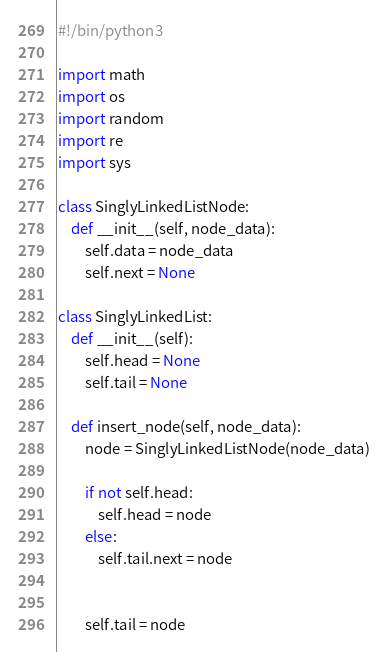Convert code to text. <code><loc_0><loc_0><loc_500><loc_500><_Python_>#!/bin/python3

import math
import os
import random
import re
import sys

class SinglyLinkedListNode:
    def __init__(self, node_data):
        self.data = node_data
        self.next = None

class SinglyLinkedList:
    def __init__(self):
        self.head = None
        self.tail = None

    def insert_node(self, node_data):
        node = SinglyLinkedListNode(node_data)

        if not self.head:
            self.head = node
        else:
            self.tail.next = node


        self.tail = node
</code> 